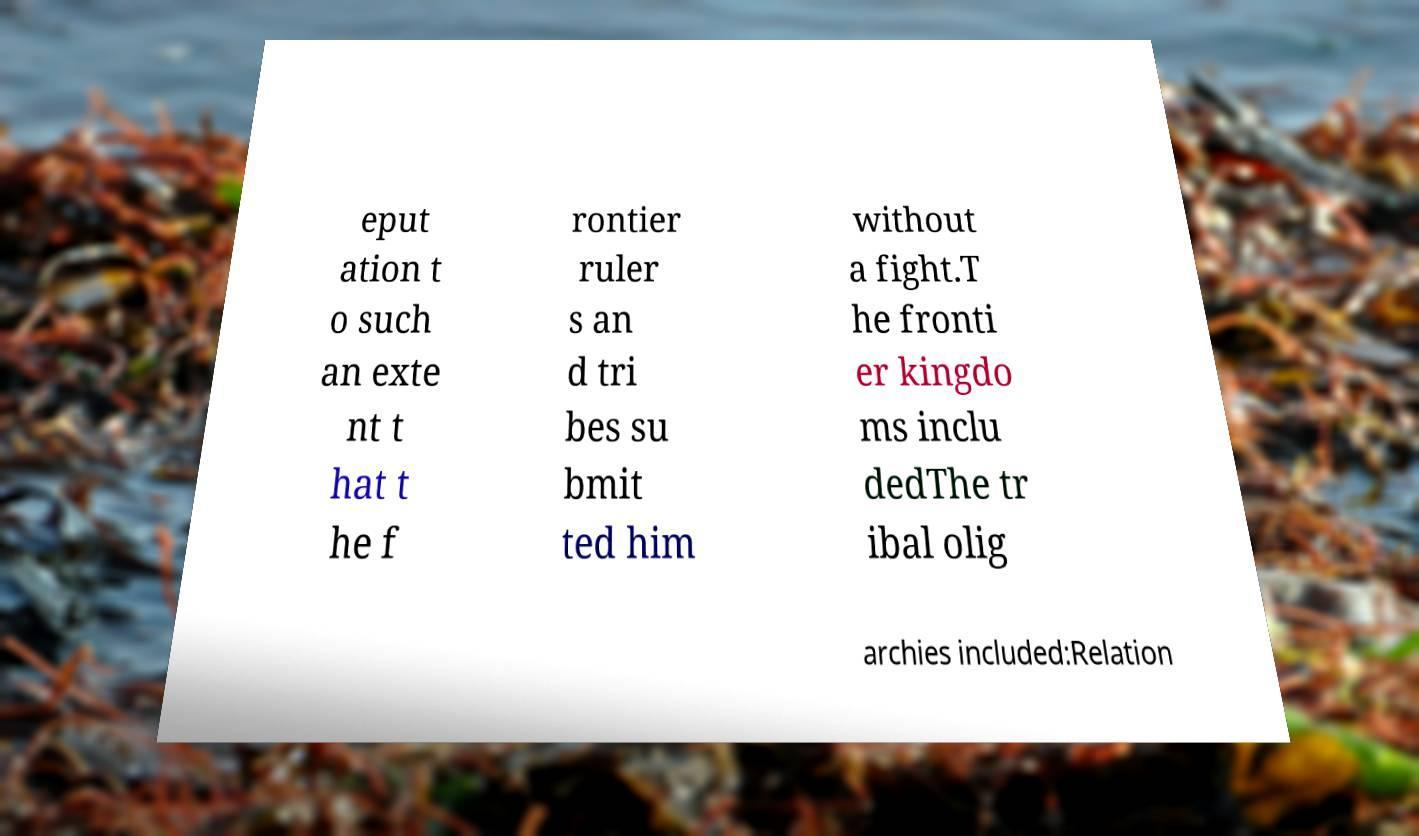Could you extract and type out the text from this image? eput ation t o such an exte nt t hat t he f rontier ruler s an d tri bes su bmit ted him without a fight.T he fronti er kingdo ms inclu dedThe tr ibal olig archies included:Relation 